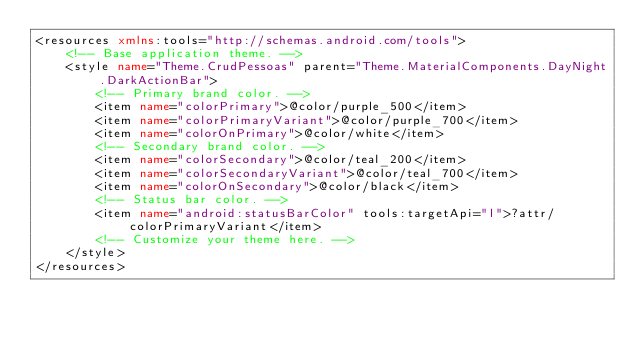Convert code to text. <code><loc_0><loc_0><loc_500><loc_500><_XML_><resources xmlns:tools="http://schemas.android.com/tools">
    <!-- Base application theme. -->
    <style name="Theme.CrudPessoas" parent="Theme.MaterialComponents.DayNight.DarkActionBar">
        <!-- Primary brand color. -->
        <item name="colorPrimary">@color/purple_500</item>
        <item name="colorPrimaryVariant">@color/purple_700</item>
        <item name="colorOnPrimary">@color/white</item>
        <!-- Secondary brand color. -->
        <item name="colorSecondary">@color/teal_200</item>
        <item name="colorSecondaryVariant">@color/teal_700</item>
        <item name="colorOnSecondary">@color/black</item>
        <!-- Status bar color. -->
        <item name="android:statusBarColor" tools:targetApi="l">?attr/colorPrimaryVariant</item>
        <!-- Customize your theme here. -->
    </style>
</resources></code> 